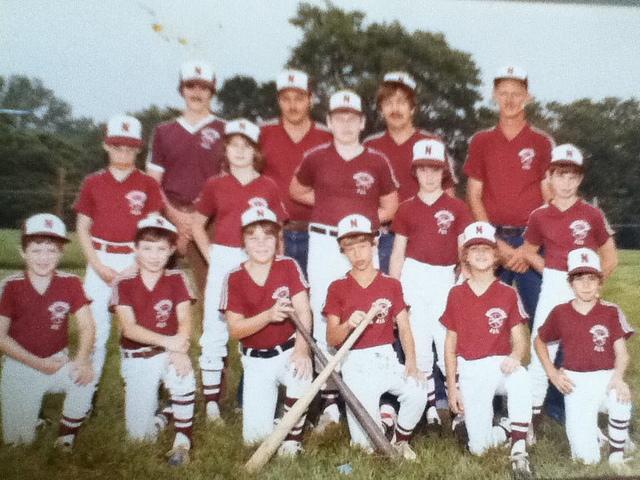How many people are in the picture?
Give a very brief answer. 15. How many kids are in the first row?
Give a very brief answer. 6. How many people are there?
Give a very brief answer. 14. How many different kinds of apples are there?
Give a very brief answer. 0. 